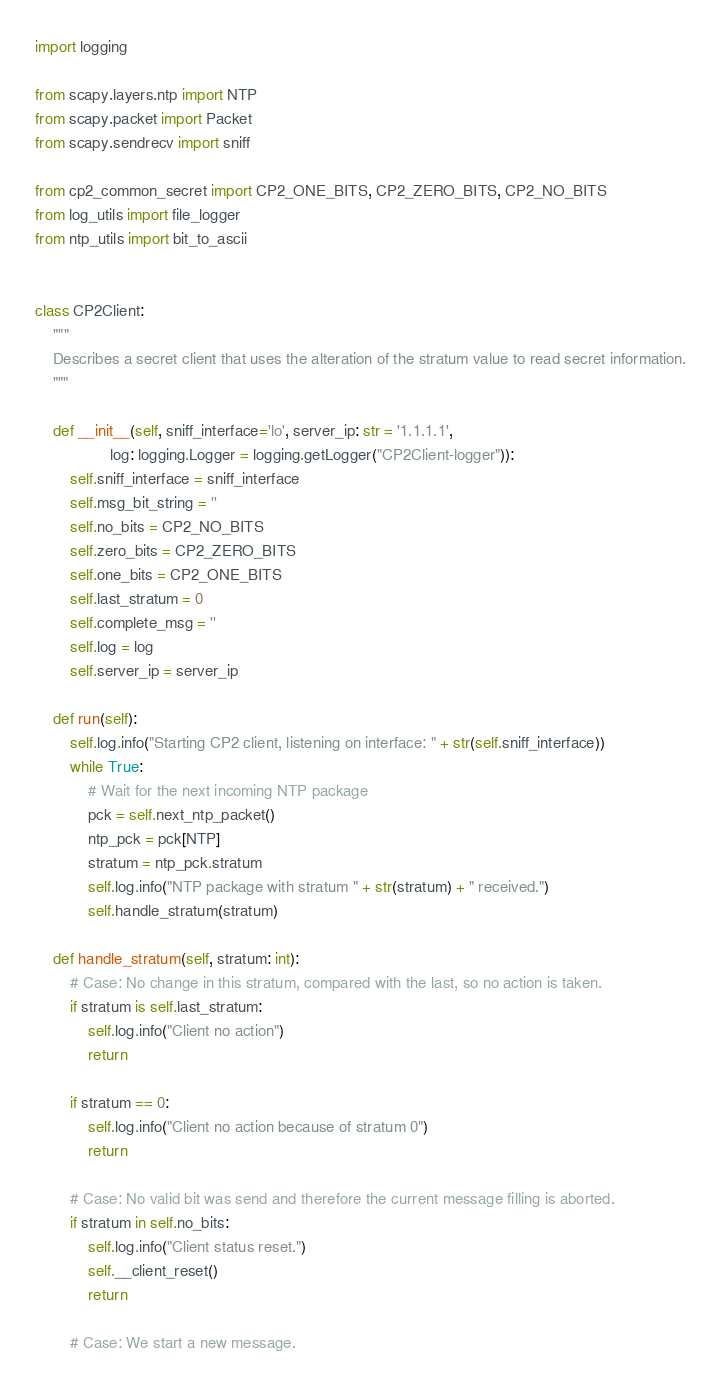<code> <loc_0><loc_0><loc_500><loc_500><_Python_>import logging

from scapy.layers.ntp import NTP
from scapy.packet import Packet
from scapy.sendrecv import sniff

from cp2_common_secret import CP2_ONE_BITS, CP2_ZERO_BITS, CP2_NO_BITS
from log_utils import file_logger
from ntp_utils import bit_to_ascii


class CP2Client:
    """
    Describes a secret client that uses the alteration of the stratum value to read secret information.
    """

    def __init__(self, sniff_interface='lo', server_ip: str = '1.1.1.1',
                 log: logging.Logger = logging.getLogger("CP2Client-logger")):
        self.sniff_interface = sniff_interface
        self.msg_bit_string = ''
        self.no_bits = CP2_NO_BITS
        self.zero_bits = CP2_ZERO_BITS
        self.one_bits = CP2_ONE_BITS
        self.last_stratum = 0
        self.complete_msg = ''
        self.log = log
        self.server_ip = server_ip

    def run(self):
        self.log.info("Starting CP2 client, listening on interface: " + str(self.sniff_interface))
        while True:
            # Wait for the next incoming NTP package
            pck = self.next_ntp_packet()
            ntp_pck = pck[NTP]
            stratum = ntp_pck.stratum
            self.log.info("NTP package with stratum " + str(stratum) + " received.")
            self.handle_stratum(stratum)

    def handle_stratum(self, stratum: int):
        # Case: No change in this stratum, compared with the last, so no action is taken.
        if stratum is self.last_stratum:
            self.log.info("Client no action")
            return

        if stratum == 0:
            self.log.info("Client no action because of stratum 0")
            return

        # Case: No valid bit was send and therefore the current message filling is aborted.
        if stratum in self.no_bits:
            self.log.info("Client status reset.")
            self.__client_reset()
            return

        # Case: We start a new message.</code> 